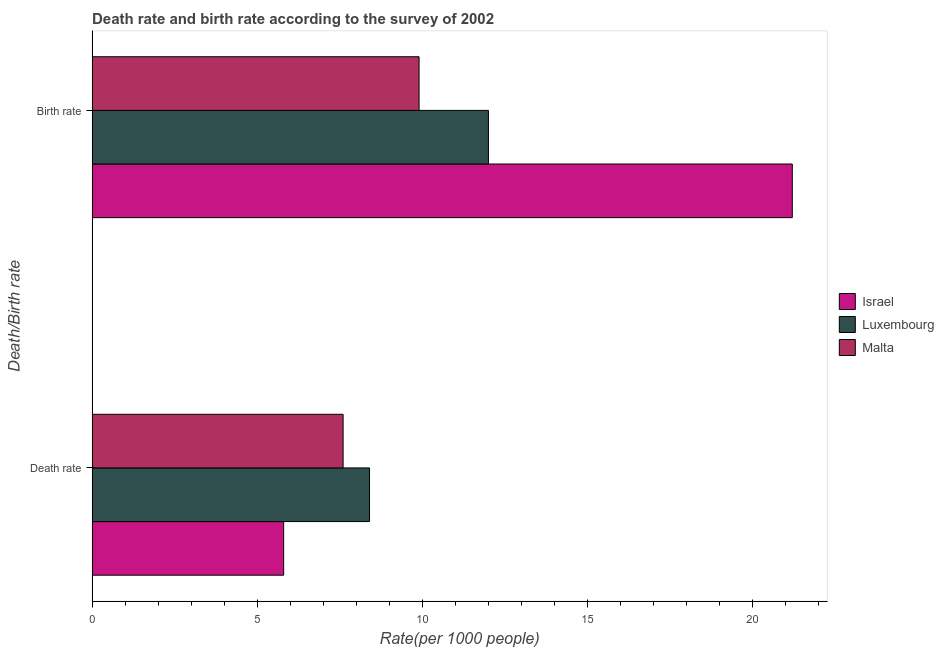How many different coloured bars are there?
Make the answer very short. 3. How many groups of bars are there?
Make the answer very short. 2. Are the number of bars per tick equal to the number of legend labels?
Make the answer very short. Yes. What is the label of the 2nd group of bars from the top?
Provide a short and direct response. Death rate. Across all countries, what is the maximum birth rate?
Your answer should be compact. 21.2. Across all countries, what is the minimum death rate?
Ensure brevity in your answer.  5.8. In which country was the death rate maximum?
Offer a terse response. Luxembourg. In which country was the birth rate minimum?
Your answer should be very brief. Malta. What is the total death rate in the graph?
Offer a terse response. 21.8. What is the difference between the death rate in Luxembourg and that in Malta?
Your answer should be compact. 0.8. What is the difference between the death rate in Israel and the birth rate in Luxembourg?
Your response must be concise. -6.2. What is the average death rate per country?
Keep it short and to the point. 7.27. What is the difference between the birth rate and death rate in Israel?
Provide a succinct answer. 15.4. What is the ratio of the death rate in Luxembourg to that in Malta?
Keep it short and to the point. 1.11. In how many countries, is the birth rate greater than the average birth rate taken over all countries?
Your answer should be very brief. 1. What does the 3rd bar from the bottom in Death rate represents?
Your response must be concise. Malta. How many bars are there?
Give a very brief answer. 6. How many countries are there in the graph?
Your answer should be very brief. 3. What is the difference between two consecutive major ticks on the X-axis?
Offer a terse response. 5. What is the title of the graph?
Provide a short and direct response. Death rate and birth rate according to the survey of 2002. What is the label or title of the X-axis?
Offer a terse response. Rate(per 1000 people). What is the label or title of the Y-axis?
Your answer should be very brief. Death/Birth rate. What is the Rate(per 1000 people) in Israel in Death rate?
Provide a short and direct response. 5.8. What is the Rate(per 1000 people) of Luxembourg in Death rate?
Offer a very short reply. 8.4. What is the Rate(per 1000 people) of Israel in Birth rate?
Provide a succinct answer. 21.2. What is the Rate(per 1000 people) in Malta in Birth rate?
Give a very brief answer. 9.9. Across all Death/Birth rate, what is the maximum Rate(per 1000 people) in Israel?
Your answer should be compact. 21.2. Across all Death/Birth rate, what is the minimum Rate(per 1000 people) of Luxembourg?
Offer a terse response. 8.4. Across all Death/Birth rate, what is the minimum Rate(per 1000 people) in Malta?
Make the answer very short. 7.6. What is the total Rate(per 1000 people) in Israel in the graph?
Ensure brevity in your answer.  27. What is the total Rate(per 1000 people) of Luxembourg in the graph?
Provide a short and direct response. 20.4. What is the total Rate(per 1000 people) in Malta in the graph?
Make the answer very short. 17.5. What is the difference between the Rate(per 1000 people) of Israel in Death rate and that in Birth rate?
Make the answer very short. -15.4. What is the difference between the Rate(per 1000 people) of Luxembourg in Death rate and that in Birth rate?
Provide a succinct answer. -3.6. What is the difference between the Rate(per 1000 people) of Malta in Death rate and that in Birth rate?
Your answer should be compact. -2.3. What is the difference between the Rate(per 1000 people) of Israel in Death rate and the Rate(per 1000 people) of Luxembourg in Birth rate?
Your answer should be compact. -6.2. What is the difference between the Rate(per 1000 people) in Israel in Death rate and the Rate(per 1000 people) in Malta in Birth rate?
Your answer should be very brief. -4.1. What is the average Rate(per 1000 people) of Israel per Death/Birth rate?
Your response must be concise. 13.5. What is the average Rate(per 1000 people) in Malta per Death/Birth rate?
Offer a terse response. 8.75. What is the difference between the Rate(per 1000 people) of Israel and Rate(per 1000 people) of Luxembourg in Birth rate?
Your response must be concise. 9.2. What is the difference between the Rate(per 1000 people) in Luxembourg and Rate(per 1000 people) in Malta in Birth rate?
Your response must be concise. 2.1. What is the ratio of the Rate(per 1000 people) of Israel in Death rate to that in Birth rate?
Give a very brief answer. 0.27. What is the ratio of the Rate(per 1000 people) in Luxembourg in Death rate to that in Birth rate?
Give a very brief answer. 0.7. What is the ratio of the Rate(per 1000 people) of Malta in Death rate to that in Birth rate?
Make the answer very short. 0.77. What is the difference between the highest and the second highest Rate(per 1000 people) of Israel?
Your answer should be compact. 15.4. What is the difference between the highest and the second highest Rate(per 1000 people) of Malta?
Offer a terse response. 2.3. What is the difference between the highest and the lowest Rate(per 1000 people) in Luxembourg?
Your answer should be very brief. 3.6. 